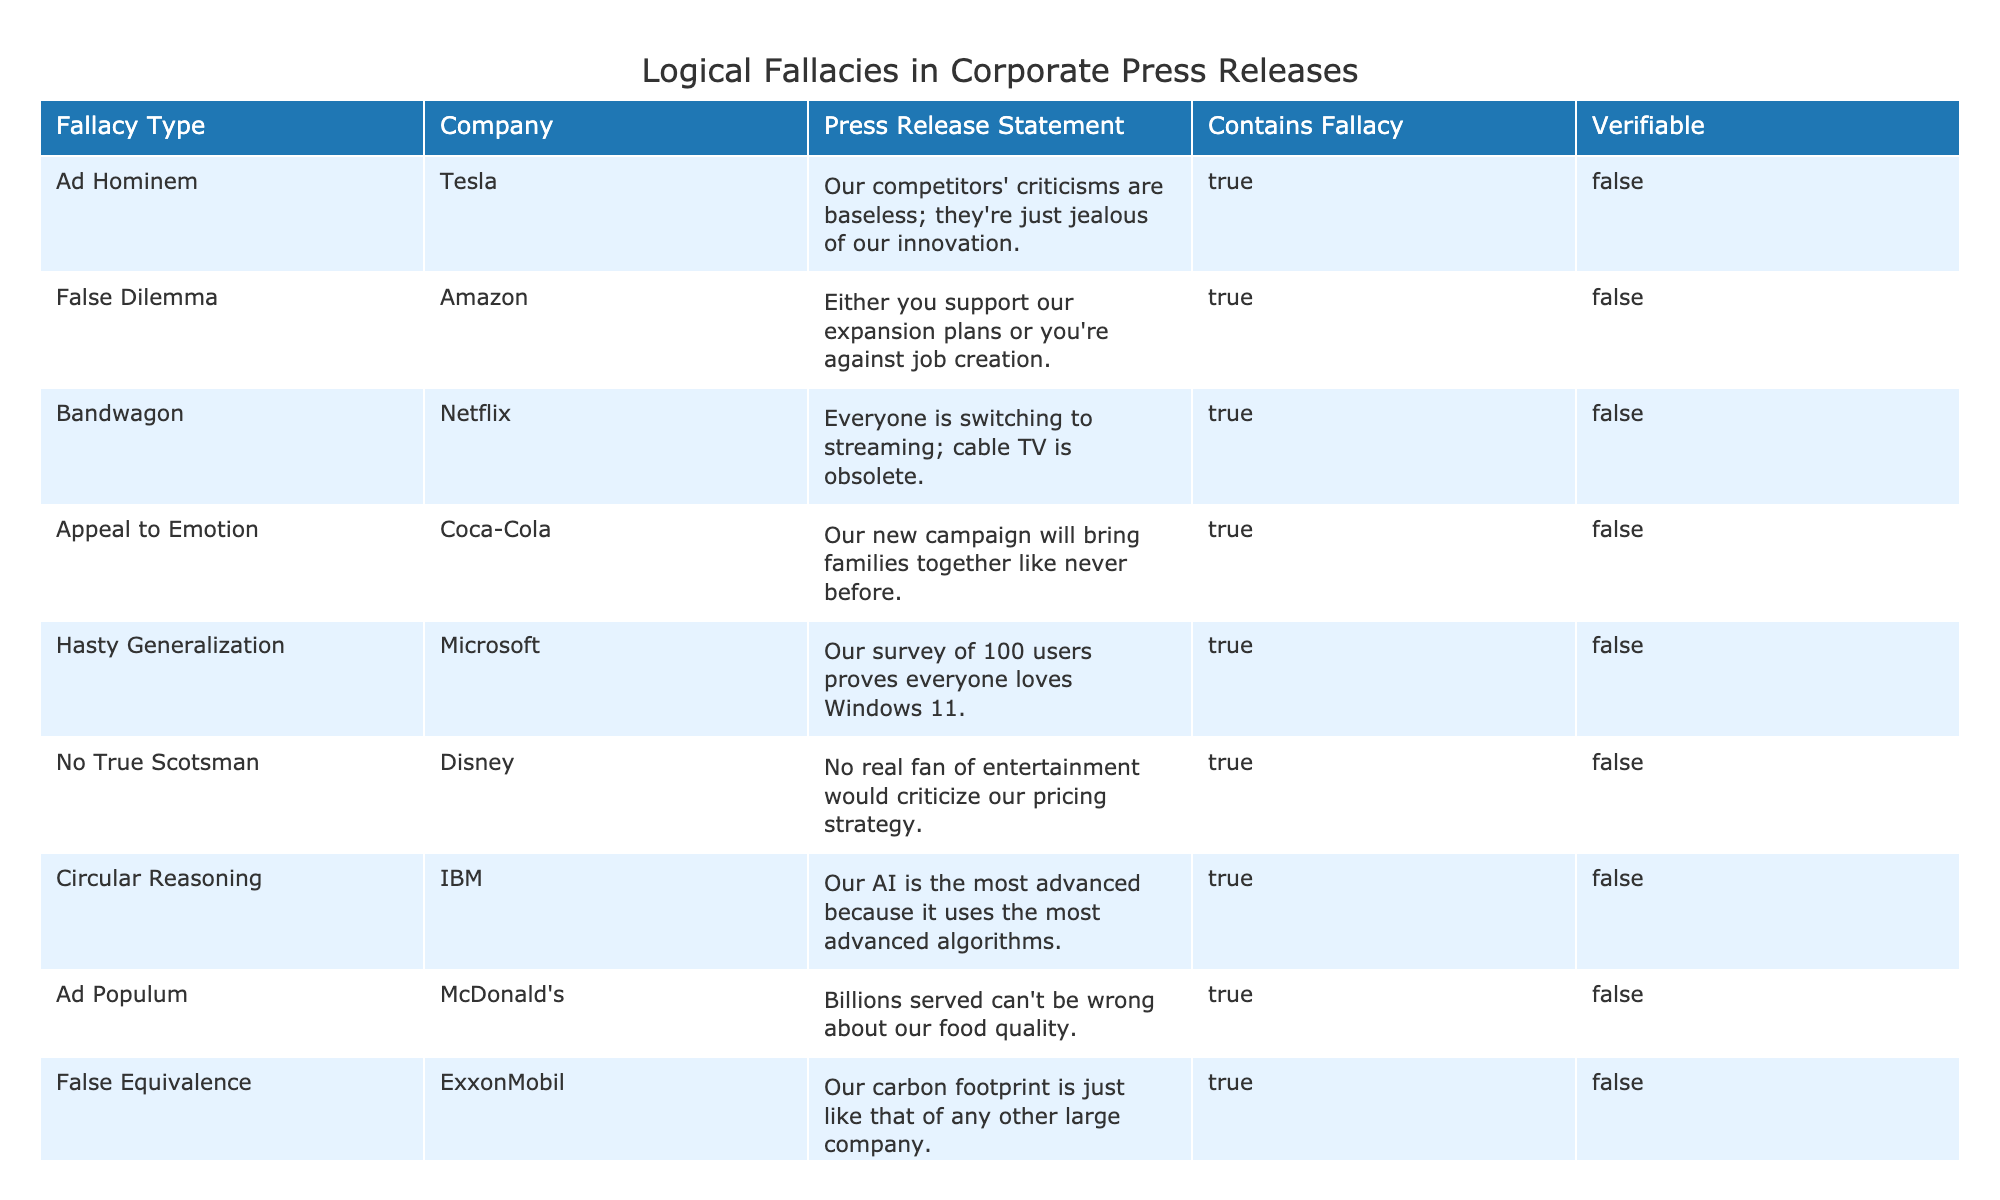What type of fallacy is associated with Tesla's press release? Referring to the table, Tesla's press release statement mentions criticisms from competitors and implies jealousy regarding innovation, which falls under the "Ad Hominem" category.
Answer: Ad Hominem How many companies use the "False Dilemma" fallacy in their press releases? By checking the table, only Amazon is listed as using the "False Dilemma" fallacy, which is evidenced in their statement about expansion plans and job creation.
Answer: 1 Does Coca-Cola's press release contain a verifiable claim? According to the table, the column indicating whether the press release statement is verifiable states "FALSE" for Coca-Cola, meaning its claims cannot be substantiated with evidence.
Answer: No What is the total number of companies that contain logical fallacies in their press releases? There are 10 listed companies in the table, all of which have statements containing logical fallacies, as indicated by the "TRUE" values in the 'Contains Fallacy' column.
Answer: 10 Which company used the "Appeal to Emotion" fallacy in their press release? The table lists Coca-Cola as using the "Appeal to Emotion" fallacy, shown in their statement regarding family togetherness from their campaign.
Answer: Coca-Cola Which fallacy type is most frequently associated with these press releases? Each fallacy in the table counts only once, hence no specific fallacy type is repeated, making it necessary to examine individual occurrences rather than a frequency count. Each listed fallacy appears once.
Answer: None is most frequent Is it true that McDonald's press release demonstrates a "Bandwagon" fallacy? The statement from McDonald's does not mention the "Bandwagon" fallacy; instead, they refer to the number of served customers to argue their food quality, which actually corresponds to the "Ad Populum" fallacy.
Answer: No What is the difference in fallacies between the statements from Pfizer and Disney? Pfizer's statement mentions anecdotal evidence about their product, categorizing it as an "Anecdotal Evidence" fallacy, while Disney's statement features a "No True Scotsman" fallacy, discrediting critics of their pricing strategy as 'real fans.'
Answer: Anecdotal Evidence; No True Scotsman 